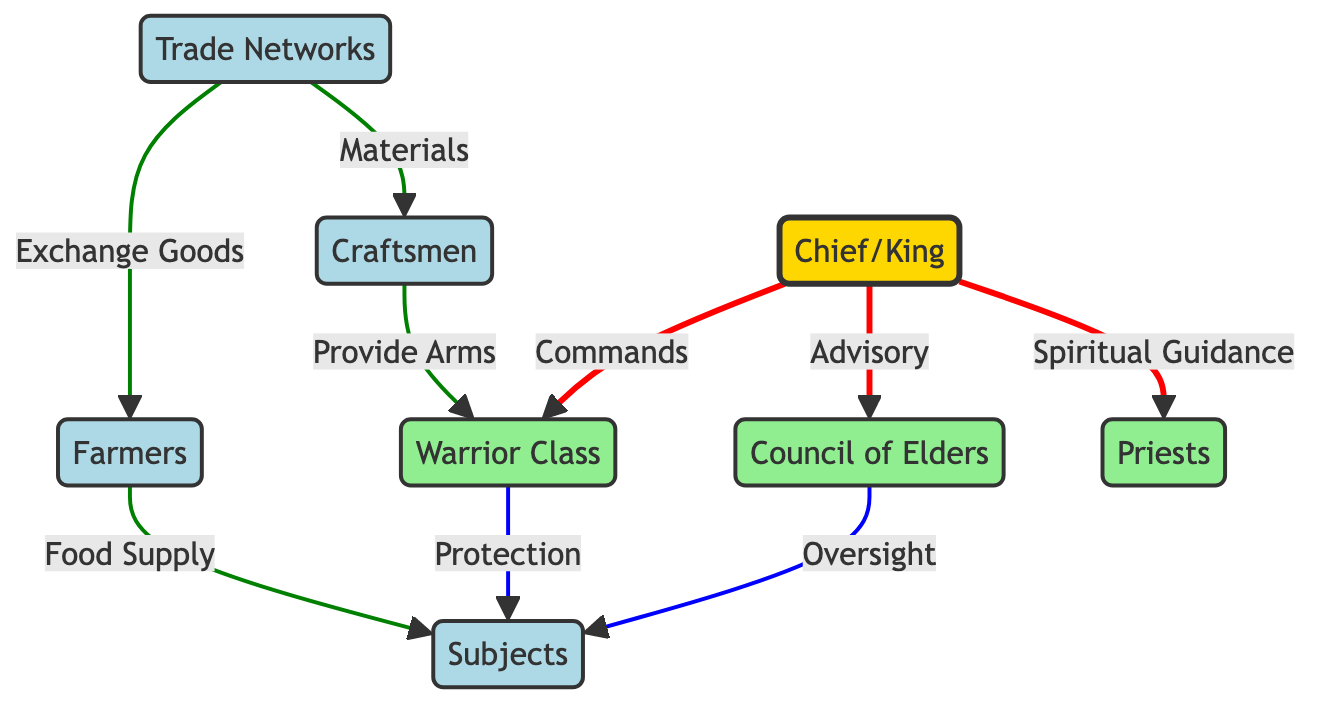What is the role of the Chief in relation to the Warriors? The diagram indicates a "Commands" relationship between the Chief and the Warriors, meaning the Chief directs and leads the Warrior Class for military purposes.
Answer: Commands How many total nodes are represented in the diagram? By counting the unique entities displayed in the diagram, we find there are eight nodes: Chief, Council of Elders, Warriors, Craftsmen, Farmers, Priests, Trade Networks, and Subjects.
Answer: 8 Which node has a connection labeled "Oversight"? The edge from the Council of Elders to the Subjects is labeled "Oversight," indicating that the Council keeps watch and maintains authority over the Subjects.
Answer: Council of Elders What is the relationship between the Farmers and the Subjects? The edge between Farmers and Subjects is labeled "Food Supply," meaning that Farmers provide necessary food resources to support the community of Subjects.
Answer: Food Supply How do Trade Networks relate to Craftsmen? The connection from Trade Networks to Craftsmen is labeled "Materials," which signifies that Trade Networks supply materials that Craftsmen require for their production activities.
Answer: Materials Which group is responsible for providing arms to the Warriors? The diagram shows that Craftsmen have a connection labeled "Provide Arms" to the Warriors, indicating that Craftsmen produce weapons and tools for the defense forces.
Answer: Craftsmen What type of diagram is being illustrated? This is a Network Diagram, which visually represents the relationships and connections among various entities, highlighting interactions and governance structures.
Answer: Network Diagram What is the total number of edges connecting the nodes? If we count the edges in the diagram, we find there are eight connections representing various relationships among the nodes.
Answer: 8 What is the primary function of the Priests in the society represented? The Priests have an edge labeled "Spiritual Guidance" from the Chief, indicating their role in providing religious instruction and support within the community.
Answer: Spiritual Guidance 